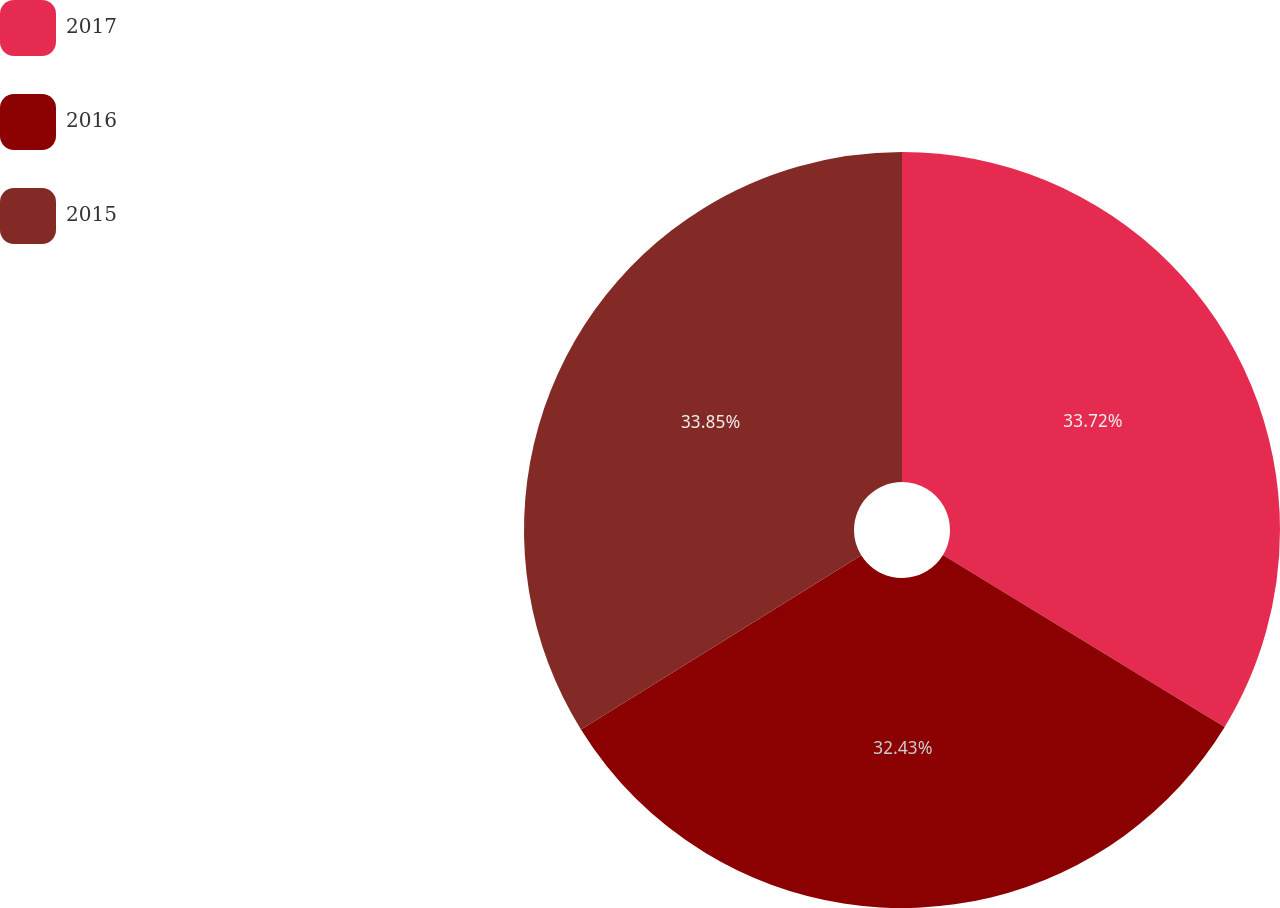<chart> <loc_0><loc_0><loc_500><loc_500><pie_chart><fcel>2017<fcel>2016<fcel>2015<nl><fcel>33.72%<fcel>32.43%<fcel>33.85%<nl></chart> 